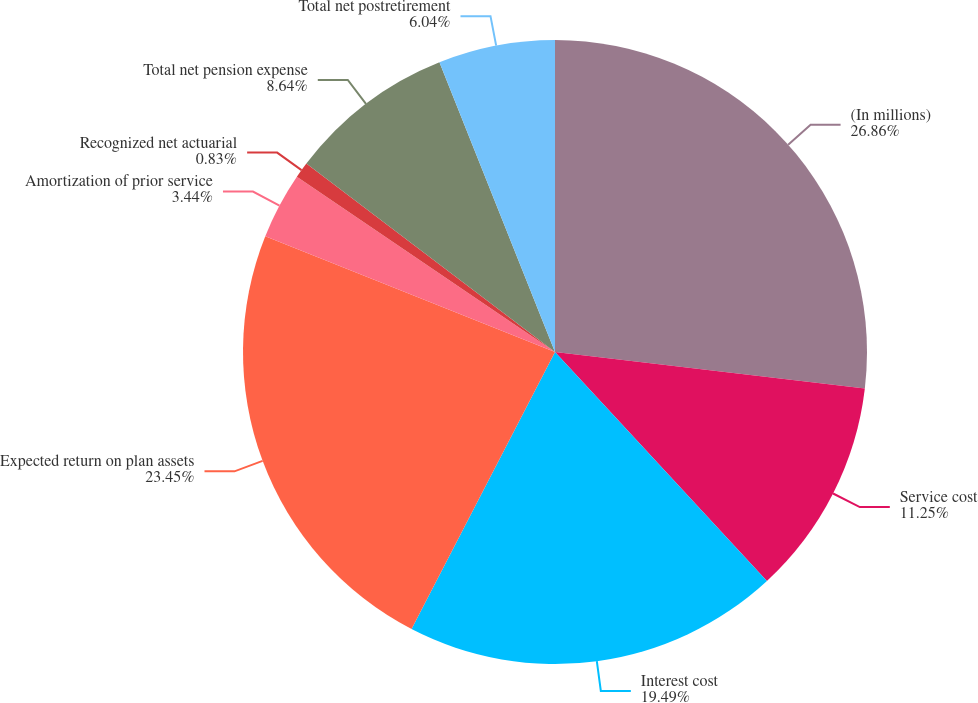Convert chart to OTSL. <chart><loc_0><loc_0><loc_500><loc_500><pie_chart><fcel>(In millions)<fcel>Service cost<fcel>Interest cost<fcel>Expected return on plan assets<fcel>Amortization of prior service<fcel>Recognized net actuarial<fcel>Total net pension expense<fcel>Total net postretirement<nl><fcel>26.87%<fcel>11.25%<fcel>19.49%<fcel>23.45%<fcel>3.44%<fcel>0.83%<fcel>8.64%<fcel>6.04%<nl></chart> 